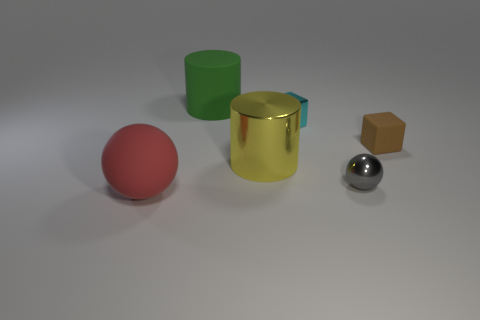There is a sphere behind the red rubber sphere; is it the same color as the cylinder that is behind the tiny cyan metallic thing? No, the sphere behind the red rubber sphere is not the same color as the cylinder behind the tiny cyan metallic thing. The sphere is a reflective silver color, while the cylinder is gold. Both have metallic finishes that make them stand out, but their colors are distinctly different. 